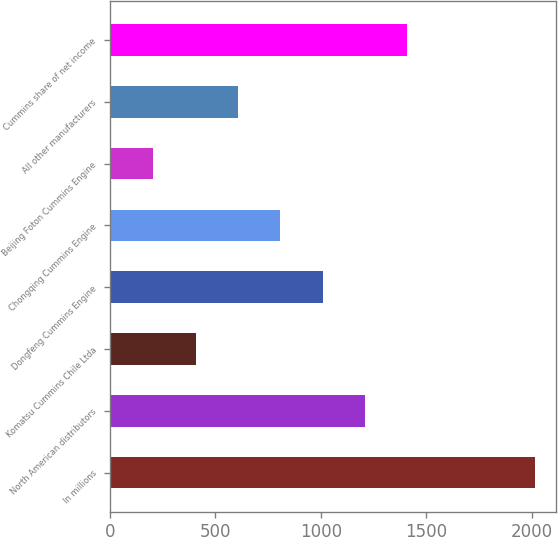<chart> <loc_0><loc_0><loc_500><loc_500><bar_chart><fcel>In millions<fcel>North American distributors<fcel>Komatsu Cummins Chile Ltda<fcel>Dongfeng Cummins Engine<fcel>Chongqing Cummins Engine<fcel>Beijing Foton Cummins Engine<fcel>All other manufacturers<fcel>Cummins share of net income<nl><fcel>2013<fcel>1209.8<fcel>406.6<fcel>1009<fcel>808.2<fcel>205.8<fcel>607.4<fcel>1410.6<nl></chart> 